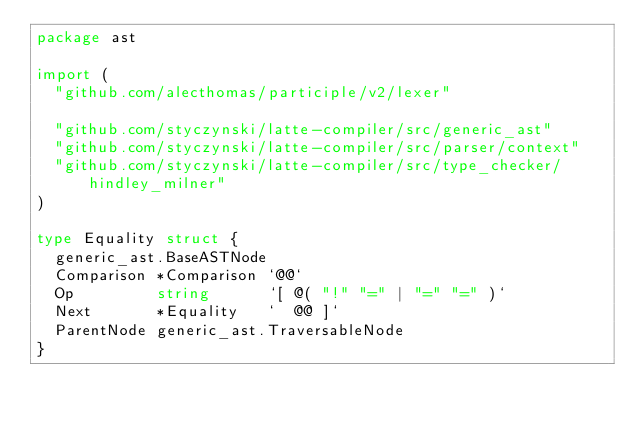Convert code to text. <code><loc_0><loc_0><loc_500><loc_500><_Go_>package ast

import (
	"github.com/alecthomas/participle/v2/lexer"

	"github.com/styczynski/latte-compiler/src/generic_ast"
	"github.com/styczynski/latte-compiler/src/parser/context"
	"github.com/styczynski/latte-compiler/src/type_checker/hindley_milner"
)

type Equality struct {
	generic_ast.BaseASTNode
	Comparison *Comparison `@@`
	Op         string      `[ @( "!" "=" | "=" "=" )`
	Next       *Equality   `  @@ ]`
	ParentNode generic_ast.TraversableNode
}
</code> 